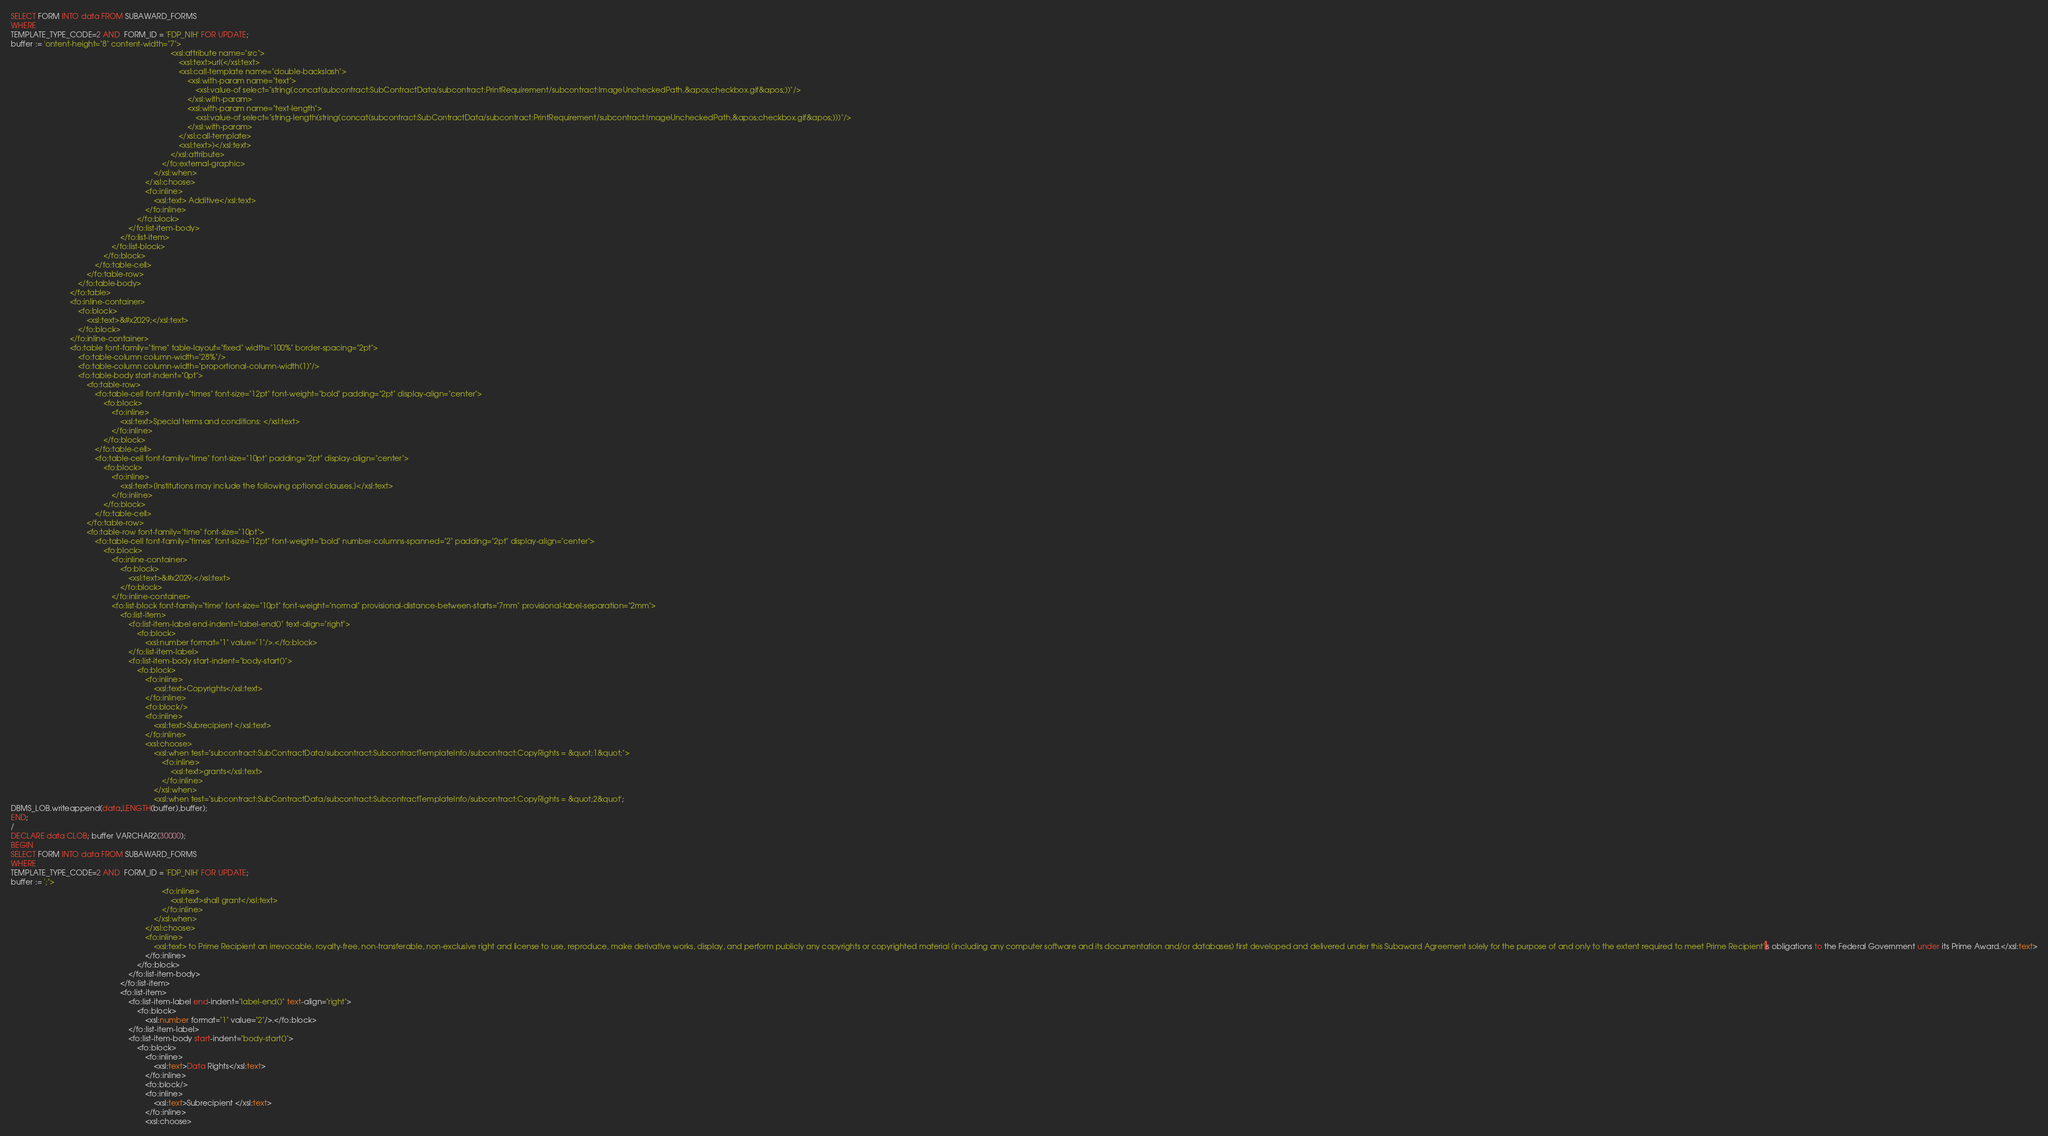<code> <loc_0><loc_0><loc_500><loc_500><_SQL_>SELECT FORM INTO data FROM SUBAWARD_FORMS
WHERE
TEMPLATE_TYPE_CODE=2 AND  FORM_ID = 'FDP_NIH' FOR UPDATE;
buffer := 'ontent-height="8" content-width="7">
																			<xsl:attribute name="src">
																				<xsl:text>url(</xsl:text>
																				<xsl:call-template name="double-backslash">
																					<xsl:with-param name="text">
																						<xsl:value-of select="string(concat(subcontract:SubContractData/subcontract:PrintRequirement/subcontract:ImageUncheckedPath,&apos;checkbox.gif&apos;))"/>
																					</xsl:with-param>
																					<xsl:with-param name="text-length">
																						<xsl:value-of select="string-length(string(concat(subcontract:SubContractData/subcontract:PrintRequirement/subcontract:ImageUncheckedPath,&apos;checkbox.gif&apos;)))"/>
																					</xsl:with-param>
																				</xsl:call-template>
																				<xsl:text>)</xsl:text>
																			</xsl:attribute>
																		</fo:external-graphic>
																	</xsl:when>
																</xsl:choose>
																<fo:inline>
																	<xsl:text> Additive</xsl:text>
																</fo:inline>
															</fo:block>
														</fo:list-item-body>
													</fo:list-item>
												</fo:list-block>
											</fo:block>
										</fo:table-cell>
									</fo:table-row>
								</fo:table-body>
							</fo:table>
							<fo:inline-container>
								<fo:block>
									<xsl:text>&#x2029;</xsl:text>
								</fo:block>
							</fo:inline-container>
							<fo:table font-family="time" table-layout="fixed" width="100%" border-spacing="2pt">
								<fo:table-column column-width="28%"/>
								<fo:table-column column-width="proportional-column-width(1)"/>
								<fo:table-body start-indent="0pt">
									<fo:table-row>
										<fo:table-cell font-family="times" font-size="12pt" font-weight="bold" padding="2pt" display-align="center">
											<fo:block>
												<fo:inline>
													<xsl:text>Special terms and conditions: </xsl:text>
												</fo:inline>
											</fo:block>
										</fo:table-cell>
										<fo:table-cell font-family="time" font-size="10pt" padding="2pt" display-align="center">
											<fo:block>
												<fo:inline>
													<xsl:text>[Institutions may include the following optional clauses.]</xsl:text>
												</fo:inline>
											</fo:block>
										</fo:table-cell>
									</fo:table-row>
									<fo:table-row font-family="time" font-size="10pt">
										<fo:table-cell font-family="times" font-size="12pt" font-weight="bold" number-columns-spanned="2" padding="2pt" display-align="center">
											<fo:block>
												<fo:inline-container>
													<fo:block>
														<xsl:text>&#x2029;</xsl:text>
													</fo:block>
												</fo:inline-container>
												<fo:list-block font-family="time" font-size="10pt" font-weight="normal" provisional-distance-between-starts="7mm" provisional-label-separation="2mm">
													<fo:list-item>
														<fo:list-item-label end-indent="label-end()" text-align="right">
															<fo:block>
																<xsl:number format="1" value="1"/>.</fo:block>
														</fo:list-item-label>
														<fo:list-item-body start-indent="body-start()">
															<fo:block>
																<fo:inline>
																	<xsl:text>Copyrights</xsl:text>
																</fo:inline>
																<fo:block/>
																<fo:inline>
																	<xsl:text>Subrecipient </xsl:text>
																</fo:inline>
																<xsl:choose>
																	<xsl:when test="subcontract:SubContractData/subcontract:SubcontractTemplateInfo/subcontract:CopyRights = &quot;1&quot;">
																		<fo:inline>
																			<xsl:text>grants</xsl:text>
																		</fo:inline>
																	</xsl:when>
																	<xsl:when test="subcontract:SubContractData/subcontract:SubcontractTemplateInfo/subcontract:CopyRights = &quot;2&quot';
DBMS_LOB.writeappend(data,LENGTH(buffer),buffer);
END;
/
DECLARE data CLOB; buffer VARCHAR2(30000);
BEGIN
SELECT FORM INTO data FROM SUBAWARD_FORMS
WHERE
TEMPLATE_TYPE_CODE=2 AND  FORM_ID = 'FDP_NIH' FOR UPDATE;
buffer := ';">
																		<fo:inline>
																			<xsl:text>shall grant</xsl:text>
																		</fo:inline>
																	</xsl:when>
																</xsl:choose>
																<fo:inline>
																	<xsl:text> to Prime Recipient an irrevocable, royalty-free, non-transferable, non-exclusive right and license to use, reproduce, make derivative works, display, and perform publicly any copyrights or copyrighted material (including any computer software and its documentation and/or databases) first developed and delivered under this Subaward Agreement solely for the purpose of and only to the extent required to meet Prime Recipient''s obligations to the Federal Government under its Prime Award.</xsl:text>
																</fo:inline>
															</fo:block>
														</fo:list-item-body>
													</fo:list-item>
													<fo:list-item>
														<fo:list-item-label end-indent="label-end()" text-align="right">
															<fo:block>
																<xsl:number format="1" value="2"/>.</fo:block>
														</fo:list-item-label>
														<fo:list-item-body start-indent="body-start()">
															<fo:block>
																<fo:inline>
																	<xsl:text>Data Rights</xsl:text>
																</fo:inline>
																<fo:block/>
																<fo:inline>
																	<xsl:text>Subrecipient </xsl:text>
																</fo:inline>
																<xsl:choose></code> 